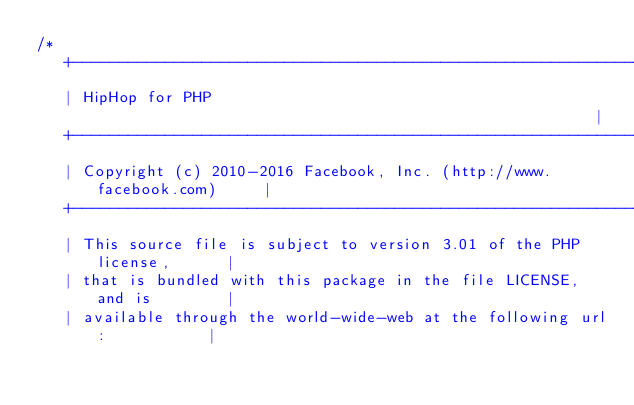<code> <loc_0><loc_0><loc_500><loc_500><_C++_>/*
   +----------------------------------------------------------------------+
   | HipHop for PHP                                                       |
   +----------------------------------------------------------------------+
   | Copyright (c) 2010-2016 Facebook, Inc. (http://www.facebook.com)     |
   +----------------------------------------------------------------------+
   | This source file is subject to version 3.01 of the PHP license,      |
   | that is bundled with this package in the file LICENSE, and is        |
   | available through the world-wide-web at the following url:           |</code> 